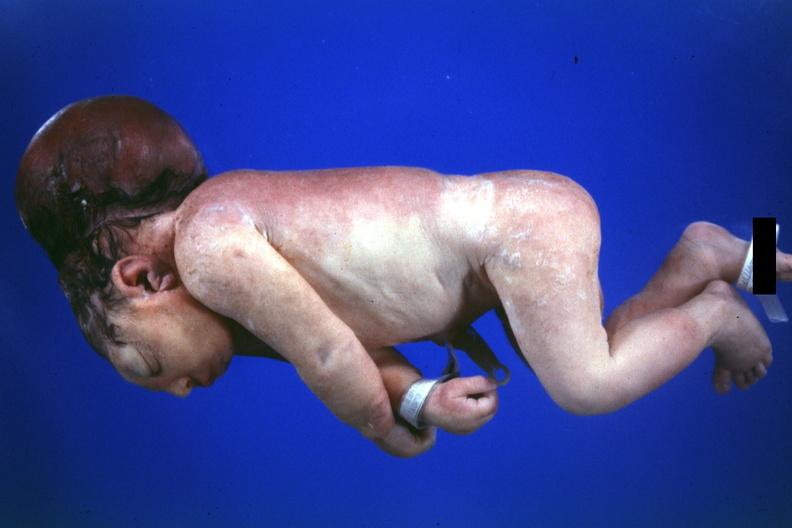what is no chromosomal defects lived?
Answer the question using a single word or phrase. One day 